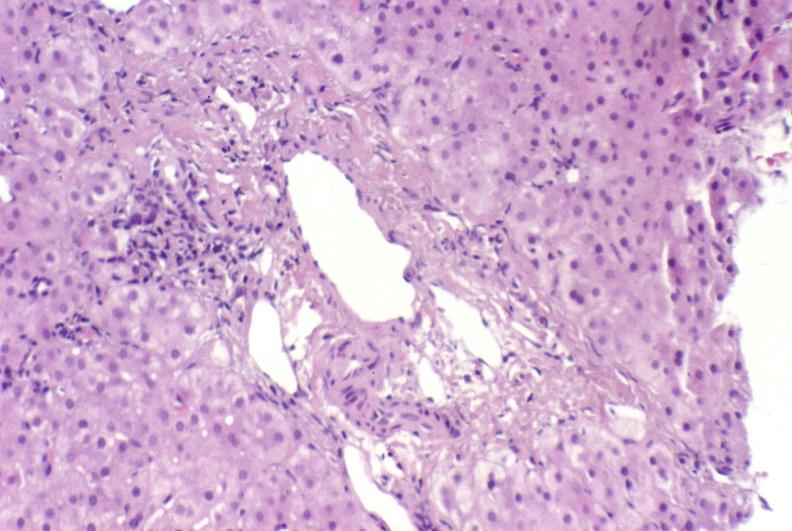what does this image show?
Answer the question using a single word or phrase. Ductopenia 